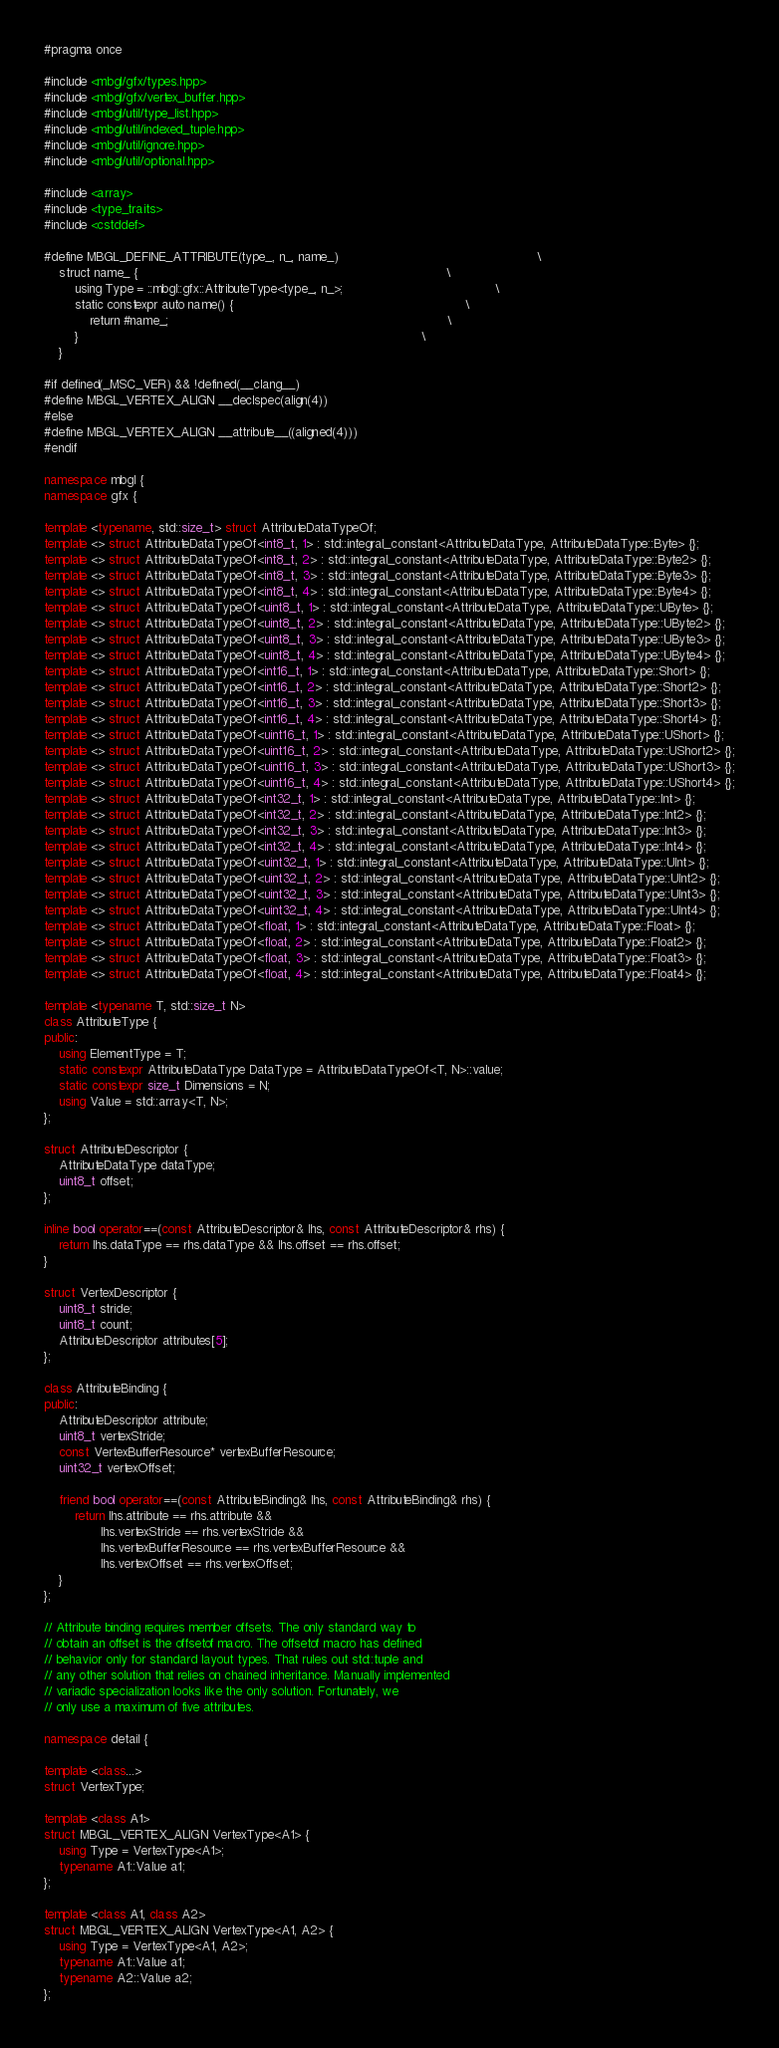Convert code to text. <code><loc_0><loc_0><loc_500><loc_500><_C++_>#pragma once

#include <mbgl/gfx/types.hpp>
#include <mbgl/gfx/vertex_buffer.hpp>
#include <mbgl/util/type_list.hpp>
#include <mbgl/util/indexed_tuple.hpp>
#include <mbgl/util/ignore.hpp>
#include <mbgl/util/optional.hpp>

#include <array>
#include <type_traits>
#include <cstddef>

#define MBGL_DEFINE_ATTRIBUTE(type_, n_, name_)                                                    \
    struct name_ {                                                                                 \
        using Type = ::mbgl::gfx::AttributeType<type_, n_>;                                        \
        static constexpr auto name() {                                                             \
            return #name_;                                                                         \
        }                                                                                          \
    }

#if defined(_MSC_VER) && !defined(__clang__)
#define MBGL_VERTEX_ALIGN __declspec(align(4))
#else
#define MBGL_VERTEX_ALIGN __attribute__((aligned(4)))
#endif

namespace mbgl {
namespace gfx {

template <typename, std::size_t> struct AttributeDataTypeOf;
template <> struct AttributeDataTypeOf<int8_t, 1> : std::integral_constant<AttributeDataType, AttributeDataType::Byte> {};
template <> struct AttributeDataTypeOf<int8_t, 2> : std::integral_constant<AttributeDataType, AttributeDataType::Byte2> {};
template <> struct AttributeDataTypeOf<int8_t, 3> : std::integral_constant<AttributeDataType, AttributeDataType::Byte3> {};
template <> struct AttributeDataTypeOf<int8_t, 4> : std::integral_constant<AttributeDataType, AttributeDataType::Byte4> {};
template <> struct AttributeDataTypeOf<uint8_t, 1> : std::integral_constant<AttributeDataType, AttributeDataType::UByte> {};
template <> struct AttributeDataTypeOf<uint8_t, 2> : std::integral_constant<AttributeDataType, AttributeDataType::UByte2> {};
template <> struct AttributeDataTypeOf<uint8_t, 3> : std::integral_constant<AttributeDataType, AttributeDataType::UByte3> {};
template <> struct AttributeDataTypeOf<uint8_t, 4> : std::integral_constant<AttributeDataType, AttributeDataType::UByte4> {};
template <> struct AttributeDataTypeOf<int16_t, 1> : std::integral_constant<AttributeDataType, AttributeDataType::Short> {};
template <> struct AttributeDataTypeOf<int16_t, 2> : std::integral_constant<AttributeDataType, AttributeDataType::Short2> {};
template <> struct AttributeDataTypeOf<int16_t, 3> : std::integral_constant<AttributeDataType, AttributeDataType::Short3> {};
template <> struct AttributeDataTypeOf<int16_t, 4> : std::integral_constant<AttributeDataType, AttributeDataType::Short4> {};
template <> struct AttributeDataTypeOf<uint16_t, 1> : std::integral_constant<AttributeDataType, AttributeDataType::UShort> {};
template <> struct AttributeDataTypeOf<uint16_t, 2> : std::integral_constant<AttributeDataType, AttributeDataType::UShort2> {};
template <> struct AttributeDataTypeOf<uint16_t, 3> : std::integral_constant<AttributeDataType, AttributeDataType::UShort3> {};
template <> struct AttributeDataTypeOf<uint16_t, 4> : std::integral_constant<AttributeDataType, AttributeDataType::UShort4> {};
template <> struct AttributeDataTypeOf<int32_t, 1> : std::integral_constant<AttributeDataType, AttributeDataType::Int> {};
template <> struct AttributeDataTypeOf<int32_t, 2> : std::integral_constant<AttributeDataType, AttributeDataType::Int2> {};
template <> struct AttributeDataTypeOf<int32_t, 3> : std::integral_constant<AttributeDataType, AttributeDataType::Int3> {};
template <> struct AttributeDataTypeOf<int32_t, 4> : std::integral_constant<AttributeDataType, AttributeDataType::Int4> {};
template <> struct AttributeDataTypeOf<uint32_t, 1> : std::integral_constant<AttributeDataType, AttributeDataType::UInt> {};
template <> struct AttributeDataTypeOf<uint32_t, 2> : std::integral_constant<AttributeDataType, AttributeDataType::UInt2> {};
template <> struct AttributeDataTypeOf<uint32_t, 3> : std::integral_constant<AttributeDataType, AttributeDataType::UInt3> {};
template <> struct AttributeDataTypeOf<uint32_t, 4> : std::integral_constant<AttributeDataType, AttributeDataType::UInt4> {};
template <> struct AttributeDataTypeOf<float, 1> : std::integral_constant<AttributeDataType, AttributeDataType::Float> {};
template <> struct AttributeDataTypeOf<float, 2> : std::integral_constant<AttributeDataType, AttributeDataType::Float2> {};
template <> struct AttributeDataTypeOf<float, 3> : std::integral_constant<AttributeDataType, AttributeDataType::Float3> {};
template <> struct AttributeDataTypeOf<float, 4> : std::integral_constant<AttributeDataType, AttributeDataType::Float4> {};

template <typename T, std::size_t N>
class AttributeType {
public:
    using ElementType = T;
    static constexpr AttributeDataType DataType = AttributeDataTypeOf<T, N>::value;
    static constexpr size_t Dimensions = N;
    using Value = std::array<T, N>;
};

struct AttributeDescriptor {
    AttributeDataType dataType;
    uint8_t offset;
};

inline bool operator==(const AttributeDescriptor& lhs, const AttributeDescriptor& rhs) {
    return lhs.dataType == rhs.dataType && lhs.offset == rhs.offset;
}

struct VertexDescriptor {
    uint8_t stride;
    uint8_t count;
    AttributeDescriptor attributes[5];
};

class AttributeBinding {
public:
    AttributeDescriptor attribute;
    uint8_t vertexStride;
    const VertexBufferResource* vertexBufferResource;
    uint32_t vertexOffset;

    friend bool operator==(const AttributeBinding& lhs, const AttributeBinding& rhs) {
        return lhs.attribute == rhs.attribute &&
               lhs.vertexStride == rhs.vertexStride &&
               lhs.vertexBufferResource == rhs.vertexBufferResource &&
               lhs.vertexOffset == rhs.vertexOffset;
    }
};

// Attribute binding requires member offsets. The only standard way to
// obtain an offset is the offsetof macro. The offsetof macro has defined
// behavior only for standard layout types. That rules out std::tuple and
// any other solution that relies on chained inheritance. Manually implemented
// variadic specialization looks like the only solution. Fortunately, we
// only use a maximum of five attributes.

namespace detail {

template <class...>
struct VertexType;

template <class A1>
struct MBGL_VERTEX_ALIGN VertexType<A1> {
    using Type = VertexType<A1>;
    typename A1::Value a1;
};

template <class A1, class A2>
struct MBGL_VERTEX_ALIGN VertexType<A1, A2> {
    using Type = VertexType<A1, A2>;
    typename A1::Value a1;
    typename A2::Value a2;
};
</code> 